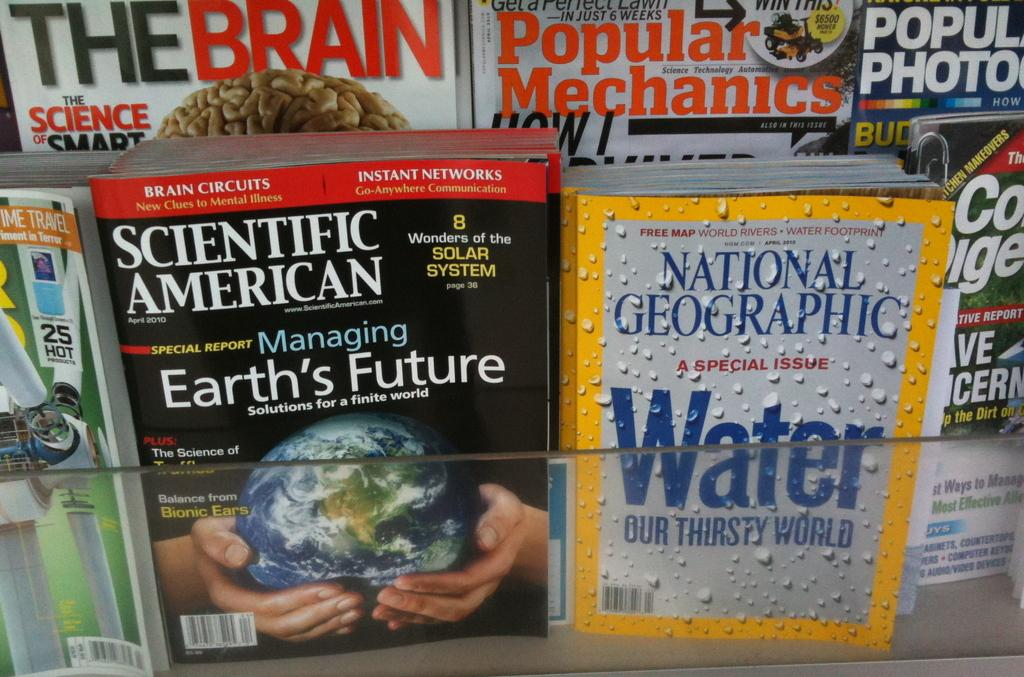<image>
Provide a brief description of the given image. A magazine rack shows titles like Scientific American and National Geographic. 